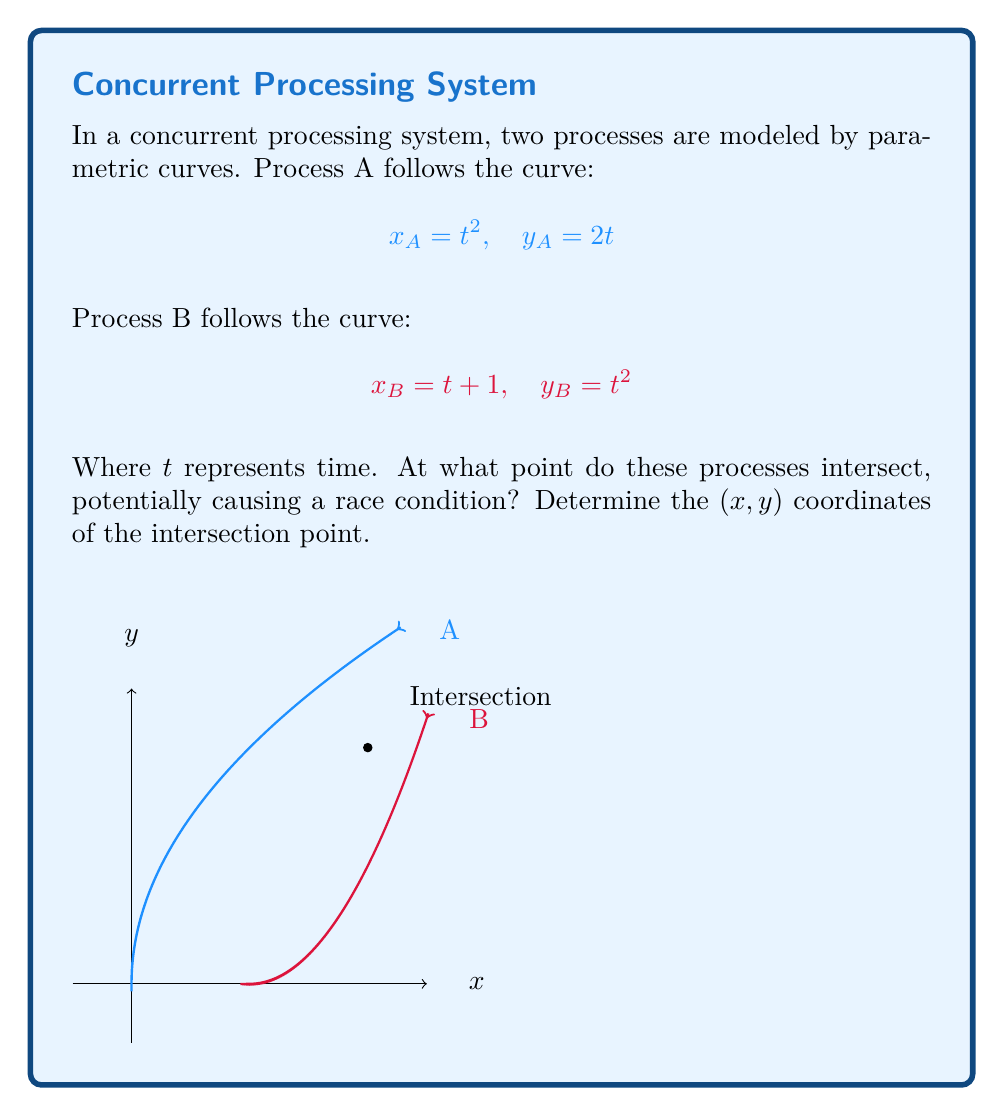Teach me how to tackle this problem. Let's approach this step-by-step:

1) For the processes to intersect, both x and y coordinates must be equal at some point. This means:

   $$x_A = x_B \text{ and } y_A = y_B$$

2) Substituting the parametric equations:

   $$t_A^2 = t_B + 1 \text{ and } 2t_A = t_B^2$$

3) From the second equation, we can express $t_A$ in terms of $t_B$:

   $$t_A = \frac{t_B^2}{2}$$

4) Substituting this into the first equation:

   $$(\frac{t_B^2}{2})^2 = t_B + 1$$

5) Simplifying:

   $$\frac{t_B^4}{4} = t_B + 1$$

6) Rearranging:

   $$t_B^4 - 4t_B - 4 = 0$$

7) This is a 4th degree equation. However, we can guess that $t_B = 2$ is a solution (as a software developer, you might appreciate this "intuitive" approach). Let's verify:

   $$2^4 - 4(2) - 4 = 16 - 8 - 4 = 4 - 4 = 0$$

8) Indeed, $t_B = 2$ is a solution. This means $t_A = \frac{2^2}{2} = 2$ as well.

9) To find the intersection point, we can use either curve's equations with $t = 2$:

   $$x = 2^2 = 4$$
   $$y = 2(2) = 4$$

Therefore, the processes intersect at the point (4, 4).
Answer: (4, 4) 